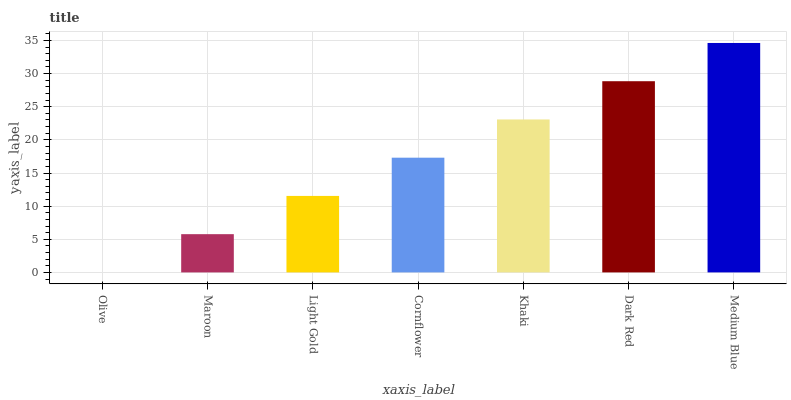Is Maroon the minimum?
Answer yes or no. No. Is Maroon the maximum?
Answer yes or no. No. Is Maroon greater than Olive?
Answer yes or no. Yes. Is Olive less than Maroon?
Answer yes or no. Yes. Is Olive greater than Maroon?
Answer yes or no. No. Is Maroon less than Olive?
Answer yes or no. No. Is Cornflower the high median?
Answer yes or no. Yes. Is Cornflower the low median?
Answer yes or no. Yes. Is Medium Blue the high median?
Answer yes or no. No. Is Light Gold the low median?
Answer yes or no. No. 